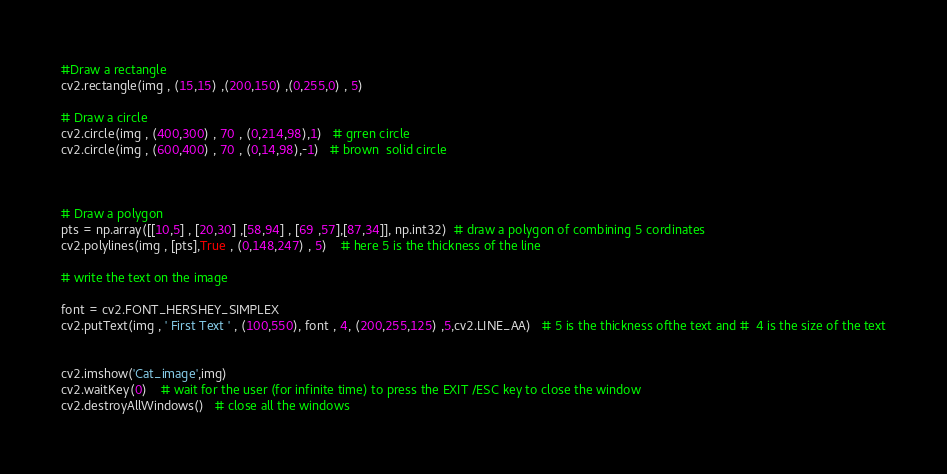<code> <loc_0><loc_0><loc_500><loc_500><_Python_>#Draw a rectangle
cv2.rectangle(img , (15,15) ,(200,150) ,(0,255,0) , 5)

# Draw a circle
cv2.circle(img , (400,300) , 70 , (0,214,98),1)   # grren circle
cv2.circle(img , (600,400) , 70 , (0,14,98),-1)   # brown  solid circle



# Draw a polygon
pts = np.array([[10,5] , [20,30] ,[58,94] , [69 ,57],[87,34]], np.int32)  # draw a polygon of combining 5 cordinates
cv2.polylines(img , [pts],True , (0,148,247) , 5)    # here 5 is the thickness of the line

# write the text on the image

font = cv2.FONT_HERSHEY_SIMPLEX
cv2.putText(img , ' First Text ' , (100,550), font , 4, (200,255,125) ,5,cv2.LINE_AA)   # 5 is the thickness ofthe text and #  4 is the size of the text


cv2.imshow('Cat_image',img)
cv2.waitKey(0)    # wait for the user (for infinite time) to press the EXIT /ESC key to close the window  
cv2.destroyAllWindows()   # close all the windows 
</code> 